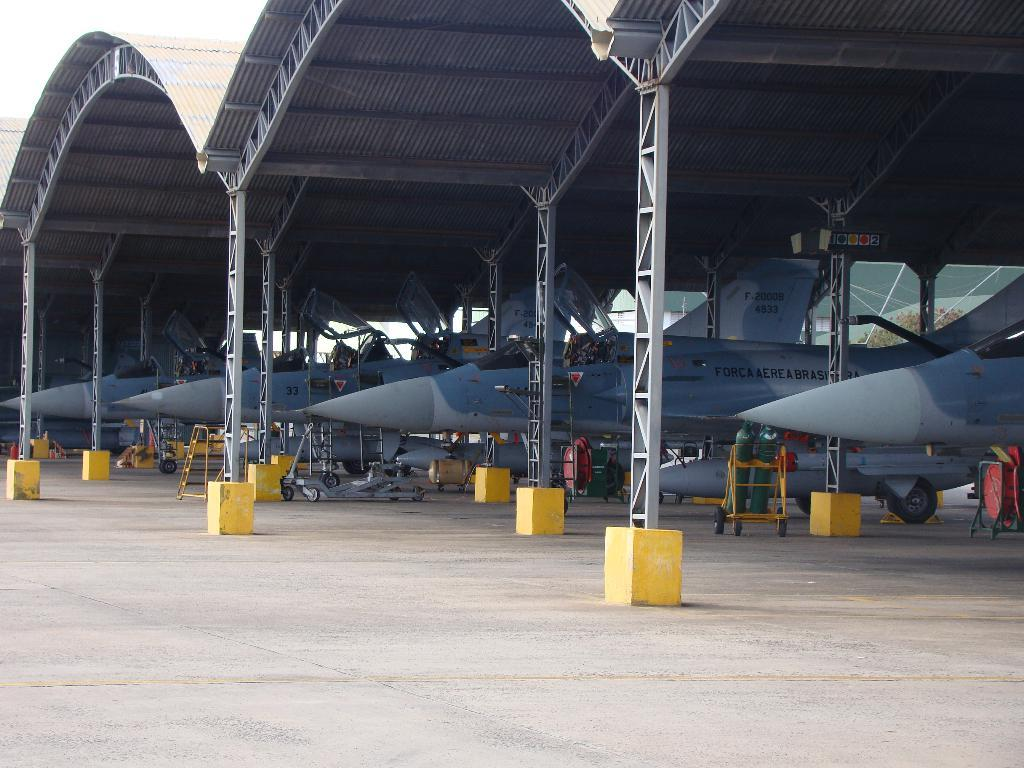<image>
Offer a succinct explanation of the picture presented. A hanger with multiple fighter aircraft with marking that reads F-20008 4933. 